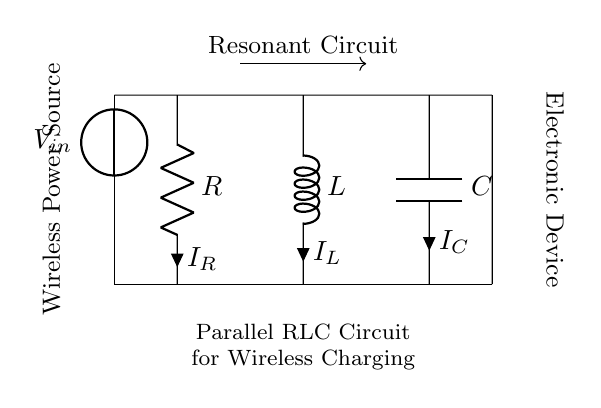What is the component labeled R? The component labeled R is a resistor, which is used to limit the current flow in the circuit.
Answer: Resistor What is the voltage source in this circuit? The voltage source in this circuit is indicated as V sub in, which provides the input voltage for the wireless power supply.
Answer: V in How many components are connected in parallel in this circuit? There are three components: one resistor, one inductor, and one capacitor all connected in parallel.
Answer: Three What is the purpose of the inductor in this circuit? The inductor is used to store energy in the magnetic field and is essential for resonant circuits, especially in wireless charging applications.
Answer: Energy storage What type of circuit is represented in this diagram? This is a parallel RLC circuit, which consists of a resistor, inductor, and capacitor connected in parallel for wireless charging of devices.
Answer: Parallel RLC circuit What is the total load current in this circuit? The total load current can be calculated by summing the individual currents through the resistor, inductor, and capacitor, which depends on the voltage and respective impedances.
Answer: Depends on voltage and impedances What does the arrow between V in and the circuit indicate? The arrow indicates the direction of the current flow from the voltage source into the parallel RLC components of the circuit.
Answer: Direction of current flow 